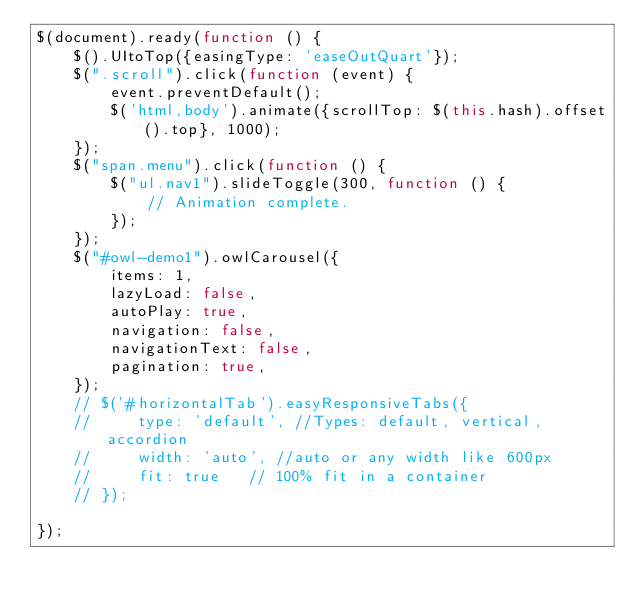<code> <loc_0><loc_0><loc_500><loc_500><_JavaScript_>$(document).ready(function () {
    $().UItoTop({easingType: 'easeOutQuart'});
    $(".scroll").click(function (event) {
        event.preventDefault();
        $('html,body').animate({scrollTop: $(this.hash).offset().top}, 1000);
    });
    $("span.menu").click(function () {
        $("ul.nav1").slideToggle(300, function () {
            // Animation complete.
        });
    });
    $("#owl-demo1").owlCarousel({
        items: 1,
        lazyLoad: false,
        autoPlay: true,
        navigation: false,
        navigationText: false,
        pagination: true,
    });
    // $('#horizontalTab').easyResponsiveTabs({
    //     type: 'default', //Types: default, vertical, accordion
    //     width: 'auto', //auto or any width like 600px
    //     fit: true   // 100% fit in a container
    // });

});</code> 